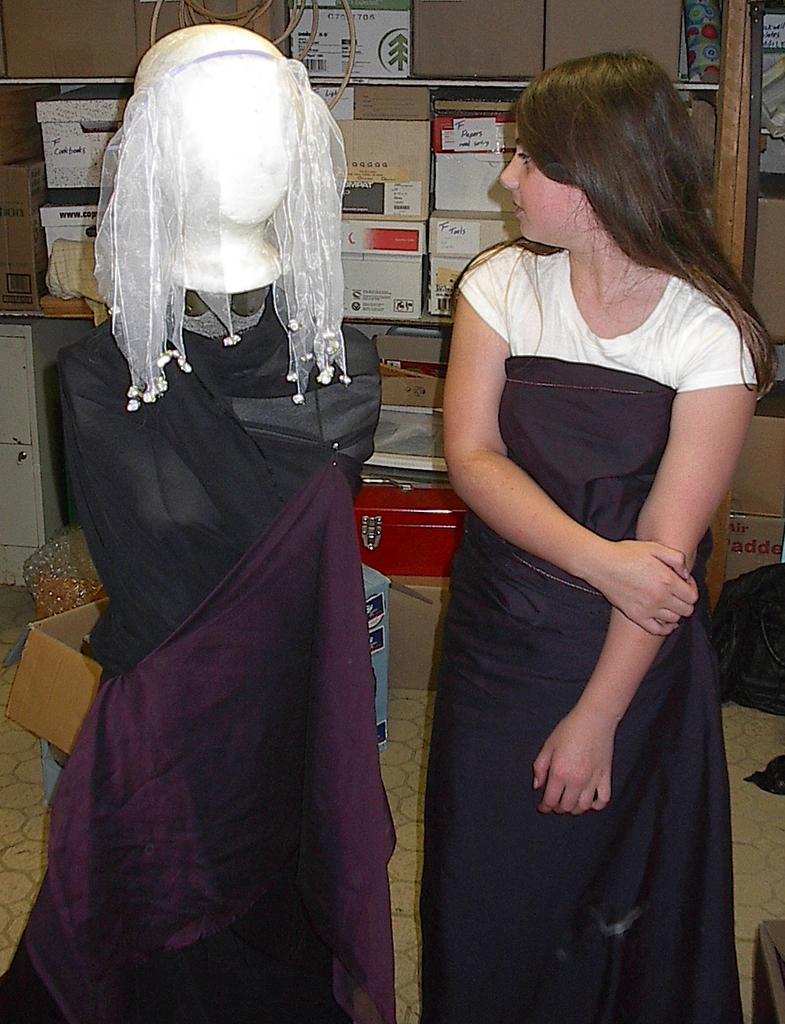Who is present in the image? There is a lady standing in the image. What is located next to the lady? There is a mannequin next to the lady. What is the mannequin wearing? Clothes are placed on the mannequin. What can be seen in the background of the image? There are cardboard boxes and a wall in the background of the image. How does the lady control the houses in the image? There are no houses present in the image, and the lady is not controlling anything in the image. 